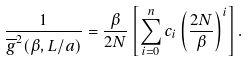Convert formula to latex. <formula><loc_0><loc_0><loc_500><loc_500>\frac { 1 } { \overline { g } ^ { 2 } ( \beta , L / a ) } = \frac { \beta } { 2 N } \left [ \sum _ { i = 0 } ^ { n } c _ { i } \left ( \frac { 2 N } { \beta } \right ) ^ { i } \right ] .</formula> 